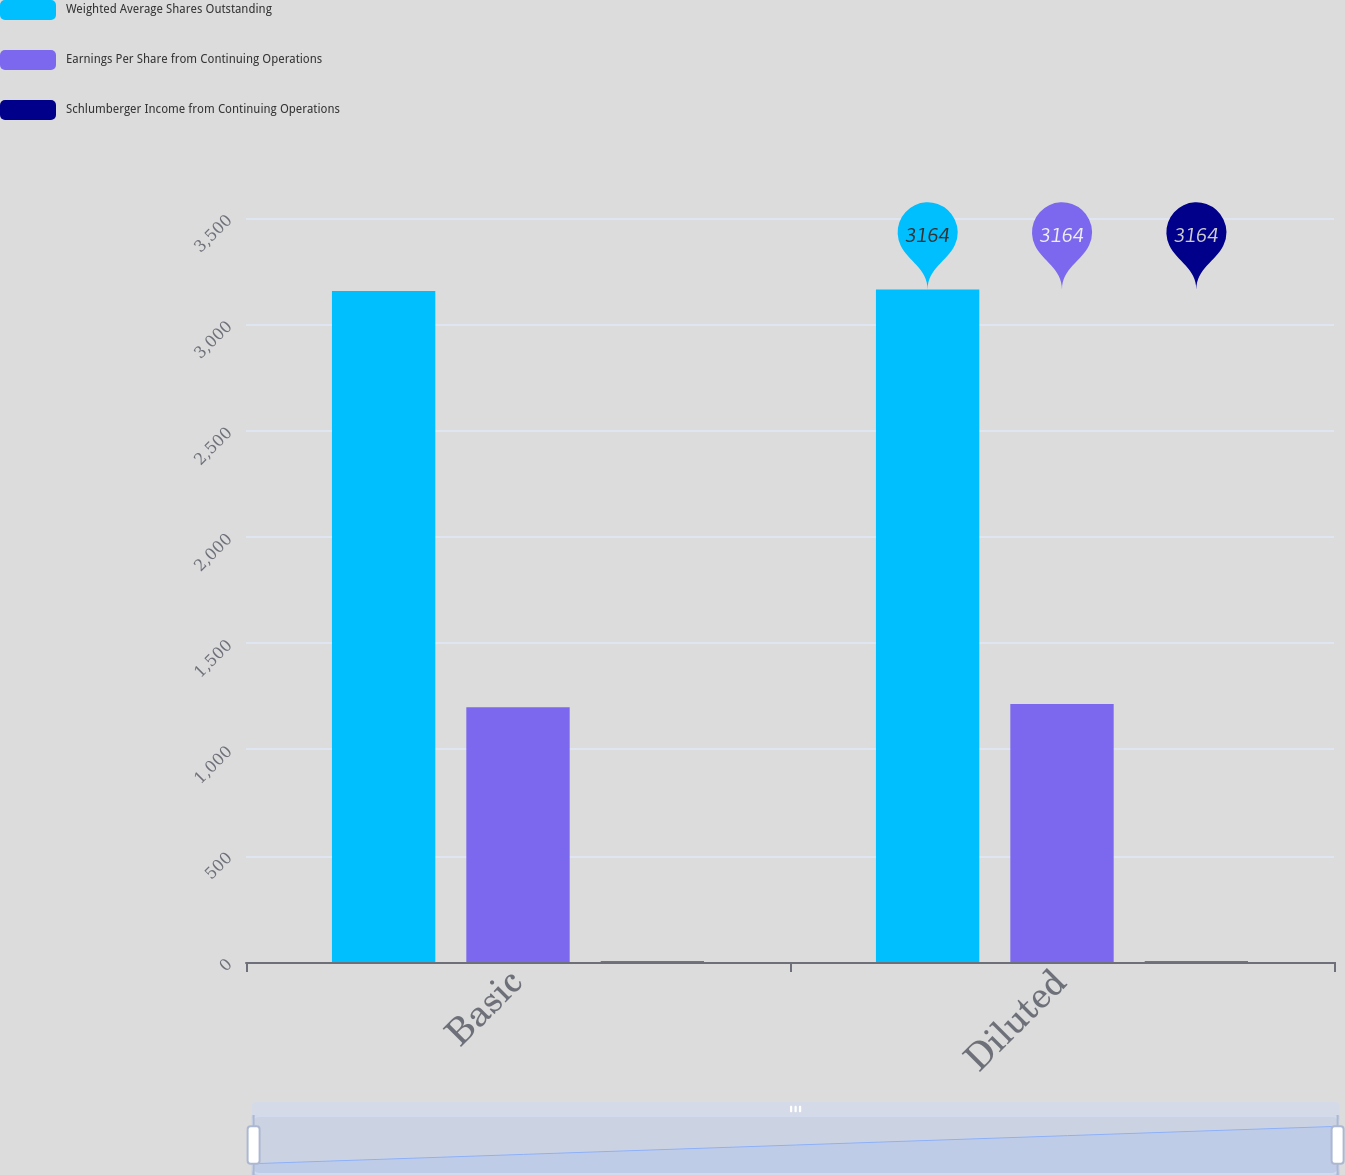Convert chart to OTSL. <chart><loc_0><loc_0><loc_500><loc_500><stacked_bar_chart><ecel><fcel>Basic<fcel>Diluted<nl><fcel>Weighted Average Shares Outstanding<fcel>3156<fcel>3164<nl><fcel>Earnings Per Share from Continuing Operations<fcel>1198<fcel>1214<nl><fcel>Schlumberger Income from Continuing Operations<fcel>2.63<fcel>2.61<nl></chart> 